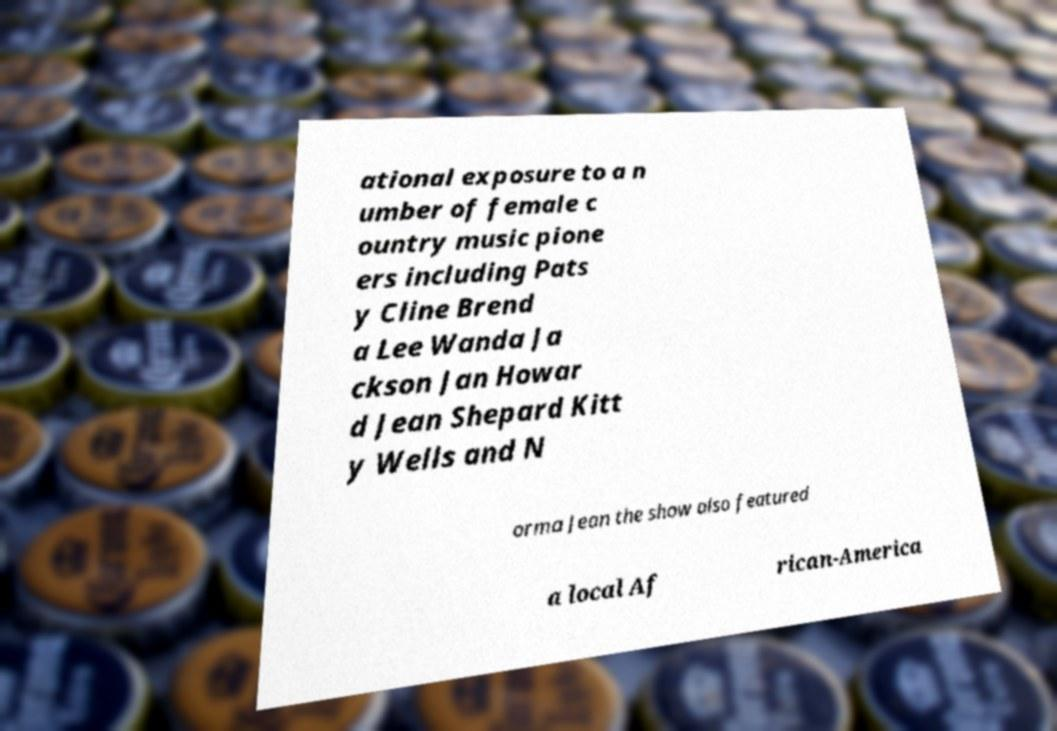For documentation purposes, I need the text within this image transcribed. Could you provide that? ational exposure to a n umber of female c ountry music pione ers including Pats y Cline Brend a Lee Wanda Ja ckson Jan Howar d Jean Shepard Kitt y Wells and N orma Jean the show also featured a local Af rican-America 